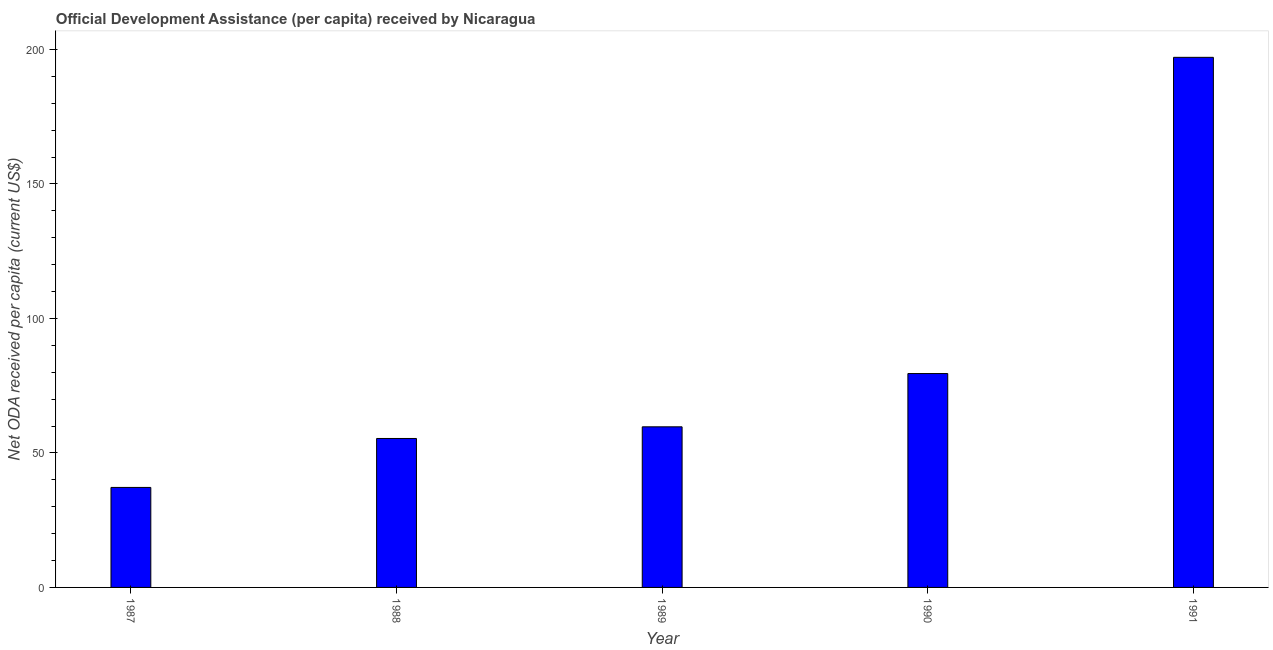What is the title of the graph?
Offer a terse response. Official Development Assistance (per capita) received by Nicaragua. What is the label or title of the Y-axis?
Ensure brevity in your answer.  Net ODA received per capita (current US$). What is the net oda received per capita in 1991?
Your response must be concise. 197.08. Across all years, what is the maximum net oda received per capita?
Ensure brevity in your answer.  197.08. Across all years, what is the minimum net oda received per capita?
Your response must be concise. 37.18. In which year was the net oda received per capita maximum?
Offer a very short reply. 1991. In which year was the net oda received per capita minimum?
Provide a short and direct response. 1987. What is the sum of the net oda received per capita?
Your response must be concise. 428.86. What is the difference between the net oda received per capita in 1988 and 1989?
Give a very brief answer. -4.34. What is the average net oda received per capita per year?
Ensure brevity in your answer.  85.77. What is the median net oda received per capita?
Offer a very short reply. 59.71. What is the ratio of the net oda received per capita in 1987 to that in 1990?
Keep it short and to the point. 0.47. Is the net oda received per capita in 1988 less than that in 1991?
Provide a short and direct response. Yes. What is the difference between the highest and the second highest net oda received per capita?
Give a very brief answer. 117.56. What is the difference between the highest and the lowest net oda received per capita?
Offer a terse response. 159.9. How many bars are there?
Make the answer very short. 5. Are all the bars in the graph horizontal?
Your answer should be very brief. No. How many years are there in the graph?
Provide a short and direct response. 5. What is the difference between two consecutive major ticks on the Y-axis?
Make the answer very short. 50. What is the Net ODA received per capita (current US$) in 1987?
Offer a terse response. 37.18. What is the Net ODA received per capita (current US$) in 1988?
Your answer should be very brief. 55.38. What is the Net ODA received per capita (current US$) of 1989?
Offer a terse response. 59.71. What is the Net ODA received per capita (current US$) in 1990?
Ensure brevity in your answer.  79.52. What is the Net ODA received per capita (current US$) of 1991?
Offer a terse response. 197.08. What is the difference between the Net ODA received per capita (current US$) in 1987 and 1988?
Your answer should be compact. -18.2. What is the difference between the Net ODA received per capita (current US$) in 1987 and 1989?
Offer a very short reply. -22.53. What is the difference between the Net ODA received per capita (current US$) in 1987 and 1990?
Make the answer very short. -42.34. What is the difference between the Net ODA received per capita (current US$) in 1987 and 1991?
Give a very brief answer. -159.9. What is the difference between the Net ODA received per capita (current US$) in 1988 and 1989?
Offer a very short reply. -4.34. What is the difference between the Net ODA received per capita (current US$) in 1988 and 1990?
Provide a short and direct response. -24.14. What is the difference between the Net ODA received per capita (current US$) in 1988 and 1991?
Make the answer very short. -141.7. What is the difference between the Net ODA received per capita (current US$) in 1989 and 1990?
Your response must be concise. -19.8. What is the difference between the Net ODA received per capita (current US$) in 1989 and 1991?
Ensure brevity in your answer.  -137.37. What is the difference between the Net ODA received per capita (current US$) in 1990 and 1991?
Give a very brief answer. -117.56. What is the ratio of the Net ODA received per capita (current US$) in 1987 to that in 1988?
Your answer should be compact. 0.67. What is the ratio of the Net ODA received per capita (current US$) in 1987 to that in 1989?
Your response must be concise. 0.62. What is the ratio of the Net ODA received per capita (current US$) in 1987 to that in 1990?
Keep it short and to the point. 0.47. What is the ratio of the Net ODA received per capita (current US$) in 1987 to that in 1991?
Your answer should be compact. 0.19. What is the ratio of the Net ODA received per capita (current US$) in 1988 to that in 1989?
Ensure brevity in your answer.  0.93. What is the ratio of the Net ODA received per capita (current US$) in 1988 to that in 1990?
Make the answer very short. 0.7. What is the ratio of the Net ODA received per capita (current US$) in 1988 to that in 1991?
Your answer should be compact. 0.28. What is the ratio of the Net ODA received per capita (current US$) in 1989 to that in 1990?
Keep it short and to the point. 0.75. What is the ratio of the Net ODA received per capita (current US$) in 1989 to that in 1991?
Offer a very short reply. 0.3. What is the ratio of the Net ODA received per capita (current US$) in 1990 to that in 1991?
Your answer should be compact. 0.4. 